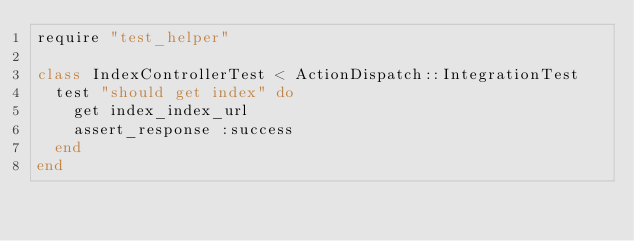Convert code to text. <code><loc_0><loc_0><loc_500><loc_500><_Ruby_>require "test_helper"

class IndexControllerTest < ActionDispatch::IntegrationTest
  test "should get index" do
    get index_index_url
    assert_response :success
  end
end
</code> 